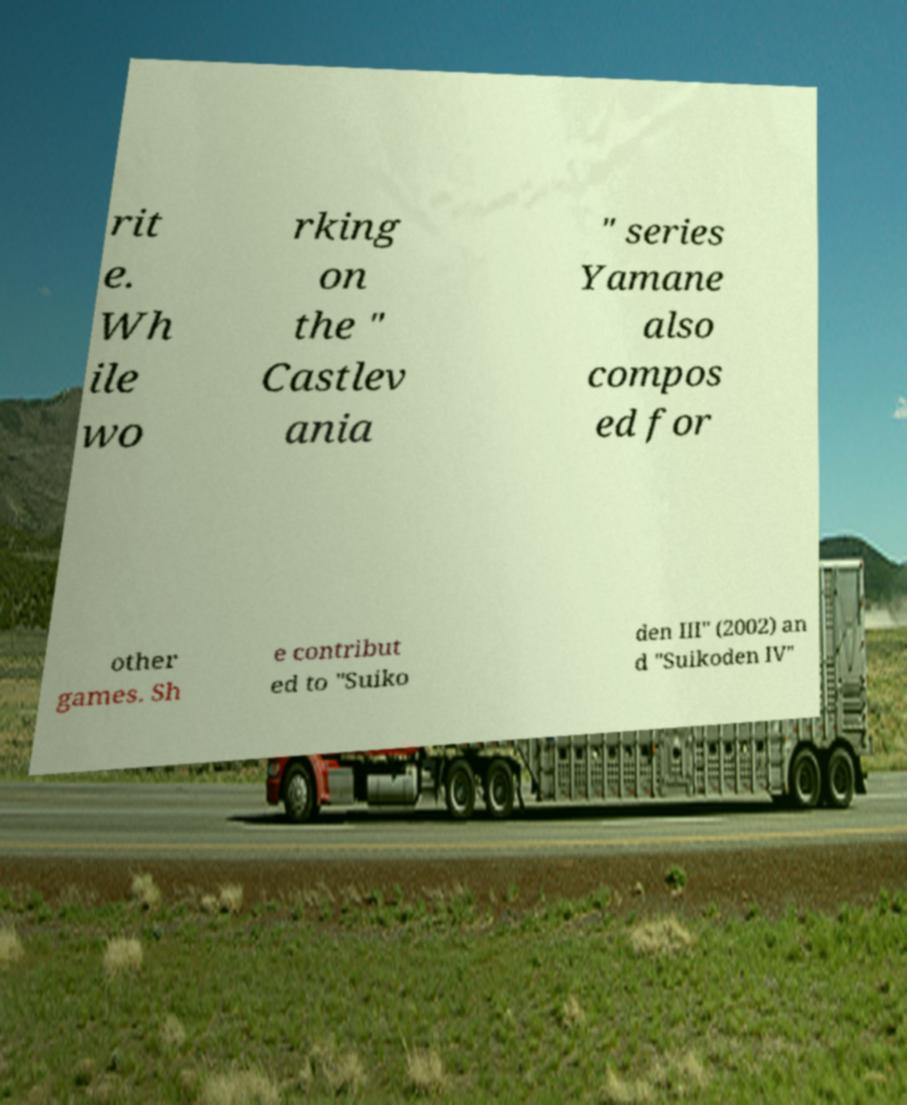Can you accurately transcribe the text from the provided image for me? rit e. Wh ile wo rking on the " Castlev ania " series Yamane also compos ed for other games. Sh e contribut ed to "Suiko den III" (2002) an d "Suikoden IV" 